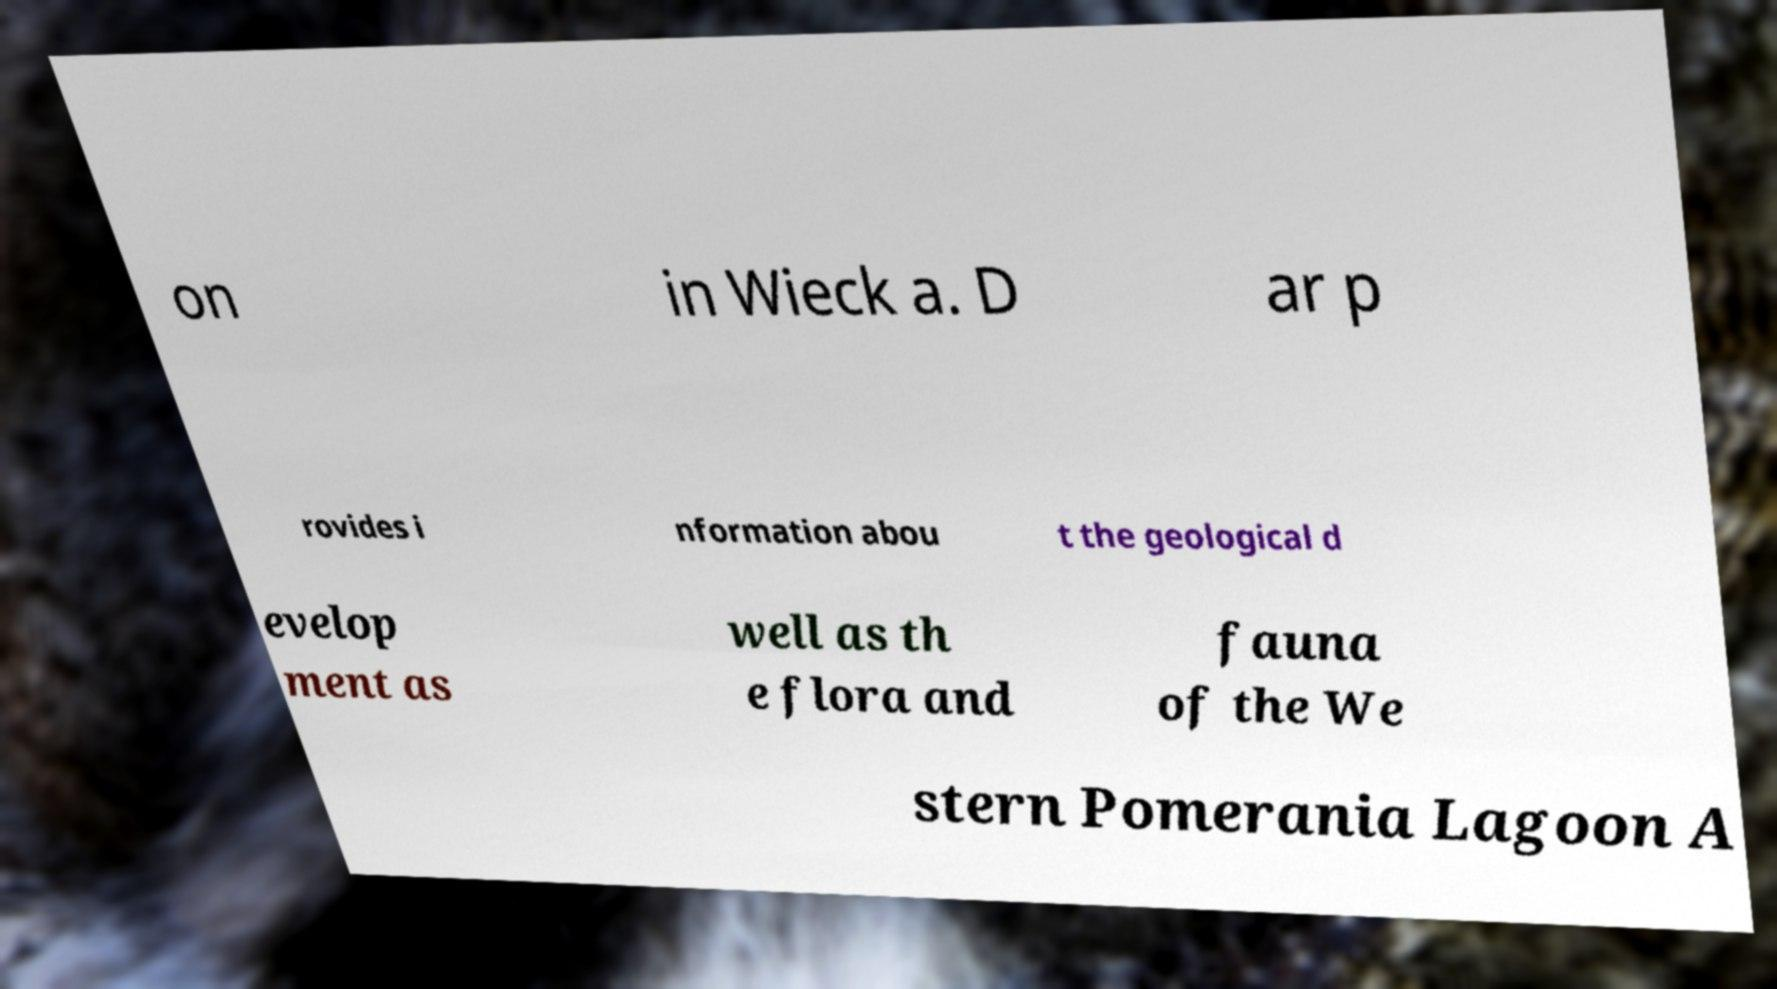Could you assist in decoding the text presented in this image and type it out clearly? on in Wieck a. D ar p rovides i nformation abou t the geological d evelop ment as well as th e flora and fauna of the We stern Pomerania Lagoon A 